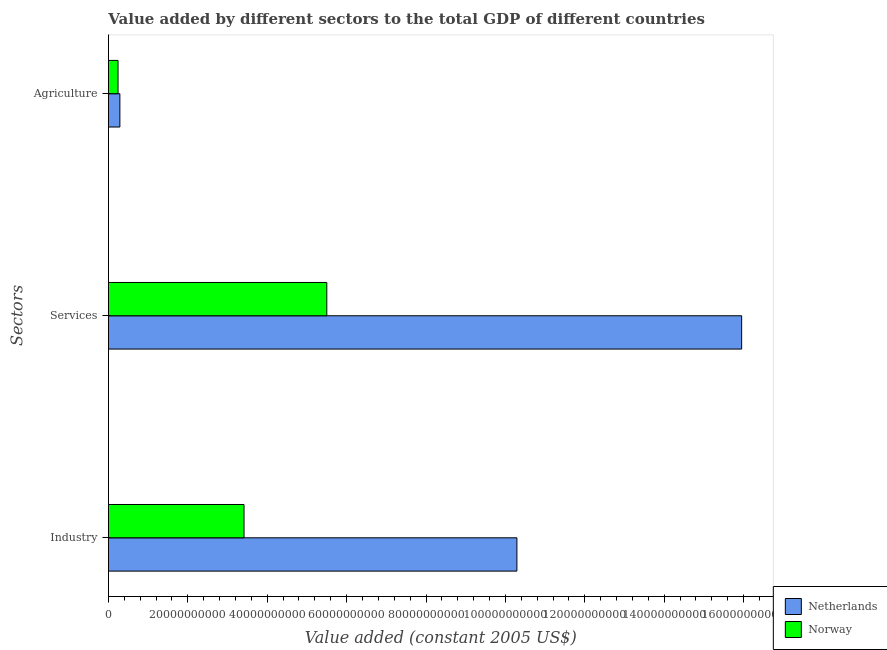How many groups of bars are there?
Provide a short and direct response. 3. Are the number of bars per tick equal to the number of legend labels?
Offer a very short reply. Yes. Are the number of bars on each tick of the Y-axis equal?
Provide a short and direct response. Yes. What is the label of the 2nd group of bars from the top?
Give a very brief answer. Services. What is the value added by agricultural sector in Netherlands?
Keep it short and to the point. 2.88e+09. Across all countries, what is the maximum value added by industrial sector?
Your answer should be very brief. 1.03e+11. Across all countries, what is the minimum value added by industrial sector?
Offer a very short reply. 3.42e+1. In which country was the value added by agricultural sector maximum?
Give a very brief answer. Netherlands. What is the total value added by agricultural sector in the graph?
Give a very brief answer. 5.30e+09. What is the difference between the value added by agricultural sector in Netherlands and that in Norway?
Your answer should be compact. 4.65e+08. What is the difference between the value added by services in Netherlands and the value added by agricultural sector in Norway?
Your answer should be very brief. 1.57e+11. What is the average value added by services per country?
Offer a terse response. 1.07e+11. What is the difference between the value added by industrial sector and value added by agricultural sector in Netherlands?
Give a very brief answer. 1.00e+11. What is the ratio of the value added by agricultural sector in Netherlands to that in Norway?
Make the answer very short. 1.19. Is the difference between the value added by industrial sector in Netherlands and Norway greater than the difference between the value added by services in Netherlands and Norway?
Your answer should be compact. No. What is the difference between the highest and the second highest value added by services?
Keep it short and to the point. 1.05e+11. What is the difference between the highest and the lowest value added by services?
Offer a very short reply. 1.05e+11. In how many countries, is the value added by industrial sector greater than the average value added by industrial sector taken over all countries?
Your answer should be compact. 1. What does the 1st bar from the top in Industry represents?
Offer a very short reply. Norway. What does the 2nd bar from the bottom in Industry represents?
Offer a terse response. Norway. How many bars are there?
Offer a very short reply. 6. What is the difference between two consecutive major ticks on the X-axis?
Offer a very short reply. 2.00e+1. Does the graph contain grids?
Make the answer very short. No. How many legend labels are there?
Give a very brief answer. 2. What is the title of the graph?
Provide a succinct answer. Value added by different sectors to the total GDP of different countries. Does "Turkey" appear as one of the legend labels in the graph?
Make the answer very short. No. What is the label or title of the X-axis?
Provide a short and direct response. Value added (constant 2005 US$). What is the label or title of the Y-axis?
Make the answer very short. Sectors. What is the Value added (constant 2005 US$) of Netherlands in Industry?
Provide a succinct answer. 1.03e+11. What is the Value added (constant 2005 US$) in Norway in Industry?
Your answer should be compact. 3.42e+1. What is the Value added (constant 2005 US$) in Netherlands in Services?
Give a very brief answer. 1.60e+11. What is the Value added (constant 2005 US$) in Norway in Services?
Provide a short and direct response. 5.50e+1. What is the Value added (constant 2005 US$) in Netherlands in Agriculture?
Make the answer very short. 2.88e+09. What is the Value added (constant 2005 US$) of Norway in Agriculture?
Provide a succinct answer. 2.42e+09. Across all Sectors, what is the maximum Value added (constant 2005 US$) of Netherlands?
Your answer should be very brief. 1.60e+11. Across all Sectors, what is the maximum Value added (constant 2005 US$) in Norway?
Give a very brief answer. 5.50e+1. Across all Sectors, what is the minimum Value added (constant 2005 US$) in Netherlands?
Make the answer very short. 2.88e+09. Across all Sectors, what is the minimum Value added (constant 2005 US$) of Norway?
Give a very brief answer. 2.42e+09. What is the total Value added (constant 2005 US$) in Netherlands in the graph?
Offer a very short reply. 2.65e+11. What is the total Value added (constant 2005 US$) of Norway in the graph?
Provide a succinct answer. 9.16e+1. What is the difference between the Value added (constant 2005 US$) of Netherlands in Industry and that in Services?
Offer a terse response. -5.66e+1. What is the difference between the Value added (constant 2005 US$) of Norway in Industry and that in Services?
Ensure brevity in your answer.  -2.08e+1. What is the difference between the Value added (constant 2005 US$) of Netherlands in Industry and that in Agriculture?
Your response must be concise. 1.00e+11. What is the difference between the Value added (constant 2005 US$) in Norway in Industry and that in Agriculture?
Your answer should be very brief. 3.17e+1. What is the difference between the Value added (constant 2005 US$) in Netherlands in Services and that in Agriculture?
Offer a terse response. 1.57e+11. What is the difference between the Value added (constant 2005 US$) of Norway in Services and that in Agriculture?
Give a very brief answer. 5.26e+1. What is the difference between the Value added (constant 2005 US$) in Netherlands in Industry and the Value added (constant 2005 US$) in Norway in Services?
Give a very brief answer. 4.79e+1. What is the difference between the Value added (constant 2005 US$) in Netherlands in Industry and the Value added (constant 2005 US$) in Norway in Agriculture?
Offer a terse response. 1.00e+11. What is the difference between the Value added (constant 2005 US$) in Netherlands in Services and the Value added (constant 2005 US$) in Norway in Agriculture?
Your answer should be compact. 1.57e+11. What is the average Value added (constant 2005 US$) in Netherlands per Sectors?
Offer a terse response. 8.84e+1. What is the average Value added (constant 2005 US$) in Norway per Sectors?
Make the answer very short. 3.05e+1. What is the difference between the Value added (constant 2005 US$) of Netherlands and Value added (constant 2005 US$) of Norway in Industry?
Make the answer very short. 6.87e+1. What is the difference between the Value added (constant 2005 US$) in Netherlands and Value added (constant 2005 US$) in Norway in Services?
Offer a terse response. 1.05e+11. What is the difference between the Value added (constant 2005 US$) of Netherlands and Value added (constant 2005 US$) of Norway in Agriculture?
Make the answer very short. 4.65e+08. What is the ratio of the Value added (constant 2005 US$) in Netherlands in Industry to that in Services?
Offer a terse response. 0.65. What is the ratio of the Value added (constant 2005 US$) in Norway in Industry to that in Services?
Give a very brief answer. 0.62. What is the ratio of the Value added (constant 2005 US$) in Netherlands in Industry to that in Agriculture?
Give a very brief answer. 35.69. What is the ratio of the Value added (constant 2005 US$) of Norway in Industry to that in Agriculture?
Provide a short and direct response. 14.13. What is the ratio of the Value added (constant 2005 US$) of Netherlands in Services to that in Agriculture?
Your response must be concise. 55.33. What is the ratio of the Value added (constant 2005 US$) in Norway in Services to that in Agriculture?
Your answer should be compact. 22.76. What is the difference between the highest and the second highest Value added (constant 2005 US$) in Netherlands?
Your response must be concise. 5.66e+1. What is the difference between the highest and the second highest Value added (constant 2005 US$) of Norway?
Your response must be concise. 2.08e+1. What is the difference between the highest and the lowest Value added (constant 2005 US$) in Netherlands?
Ensure brevity in your answer.  1.57e+11. What is the difference between the highest and the lowest Value added (constant 2005 US$) in Norway?
Your response must be concise. 5.26e+1. 